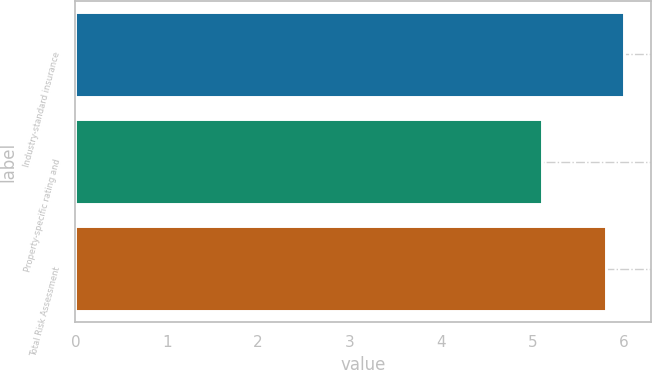Convert chart. <chart><loc_0><loc_0><loc_500><loc_500><bar_chart><fcel>Industry-standard insurance<fcel>Property-specific rating and<fcel>Total Risk Assessment<nl><fcel>6<fcel>5.1<fcel>5.8<nl></chart> 